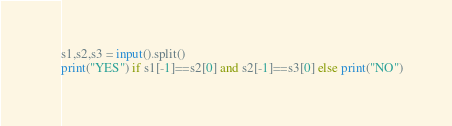<code> <loc_0><loc_0><loc_500><loc_500><_Python_>s1,s2,s3 = input().split()
print("YES") if s1[-1]==s2[0] and s2[-1]==s3[0] else print("NO")</code> 